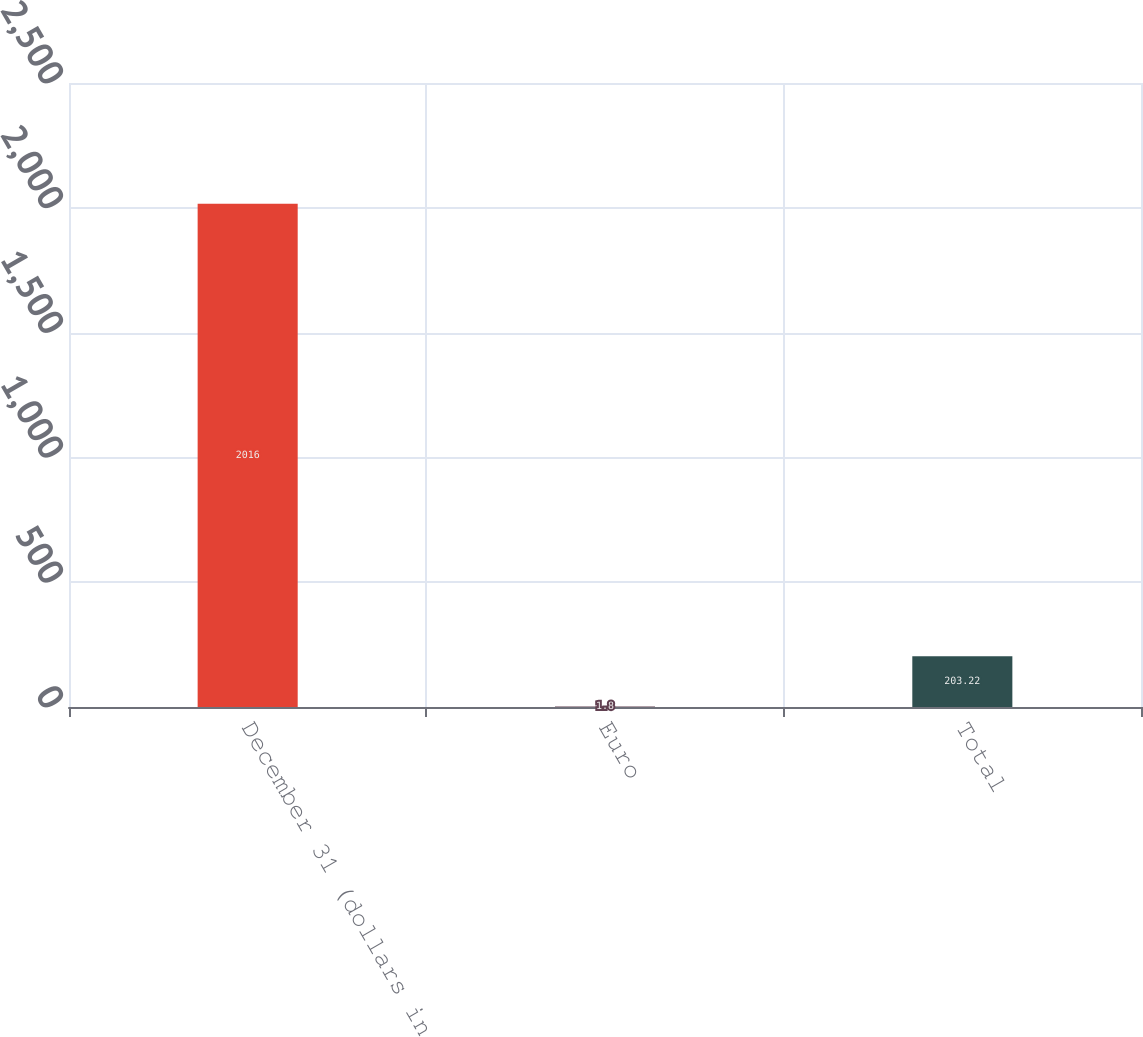Convert chart. <chart><loc_0><loc_0><loc_500><loc_500><bar_chart><fcel>December 31 (dollars in<fcel>Euro<fcel>Total<nl><fcel>2016<fcel>1.8<fcel>203.22<nl></chart> 